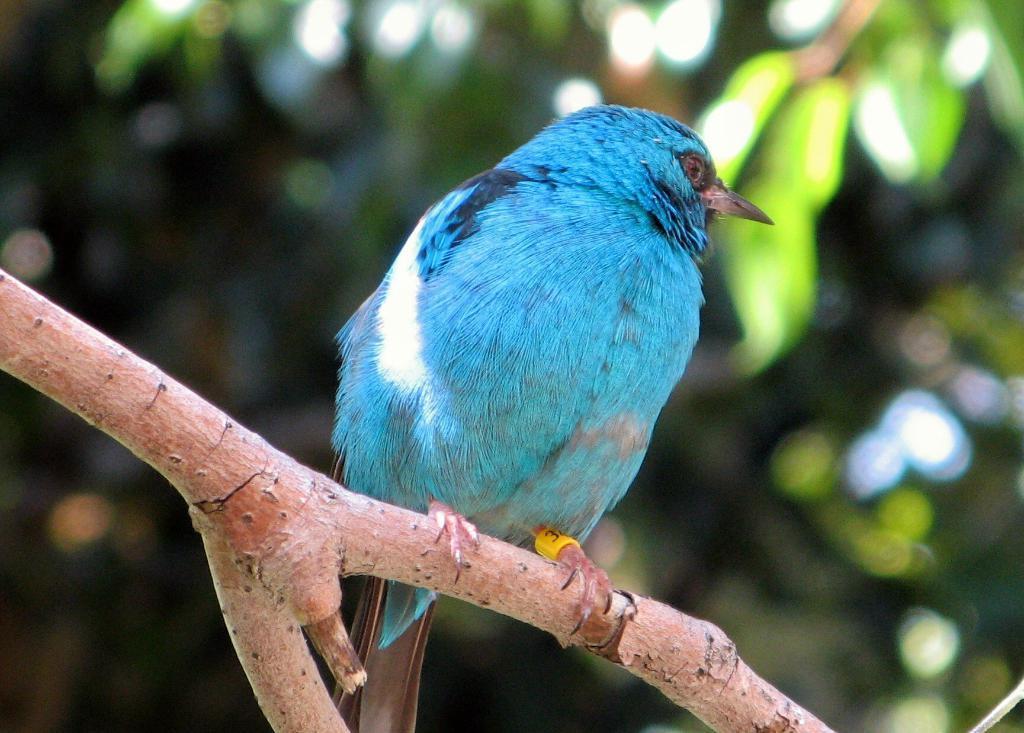In one or two sentences, can you explain what this image depicts? In this image we can see a bird on the branch of a tree. 